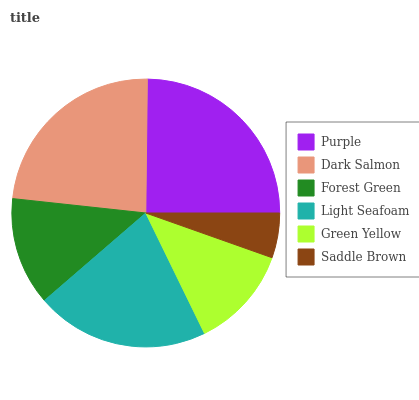Is Saddle Brown the minimum?
Answer yes or no. Yes. Is Purple the maximum?
Answer yes or no. Yes. Is Dark Salmon the minimum?
Answer yes or no. No. Is Dark Salmon the maximum?
Answer yes or no. No. Is Purple greater than Dark Salmon?
Answer yes or no. Yes. Is Dark Salmon less than Purple?
Answer yes or no. Yes. Is Dark Salmon greater than Purple?
Answer yes or no. No. Is Purple less than Dark Salmon?
Answer yes or no. No. Is Light Seafoam the high median?
Answer yes or no. Yes. Is Forest Green the low median?
Answer yes or no. Yes. Is Dark Salmon the high median?
Answer yes or no. No. Is Dark Salmon the low median?
Answer yes or no. No. 